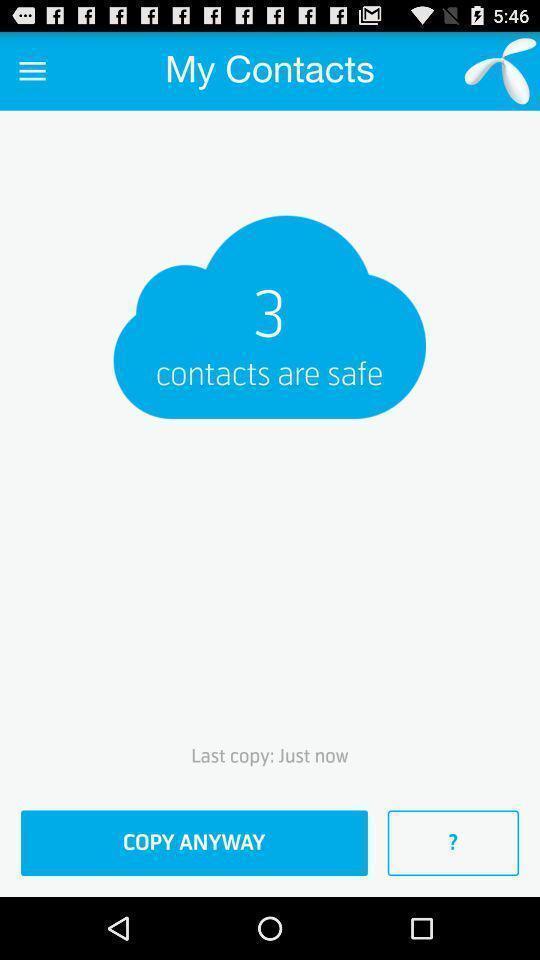Summarize the main components in this picture. Page requesting to copy contacts on an app. 